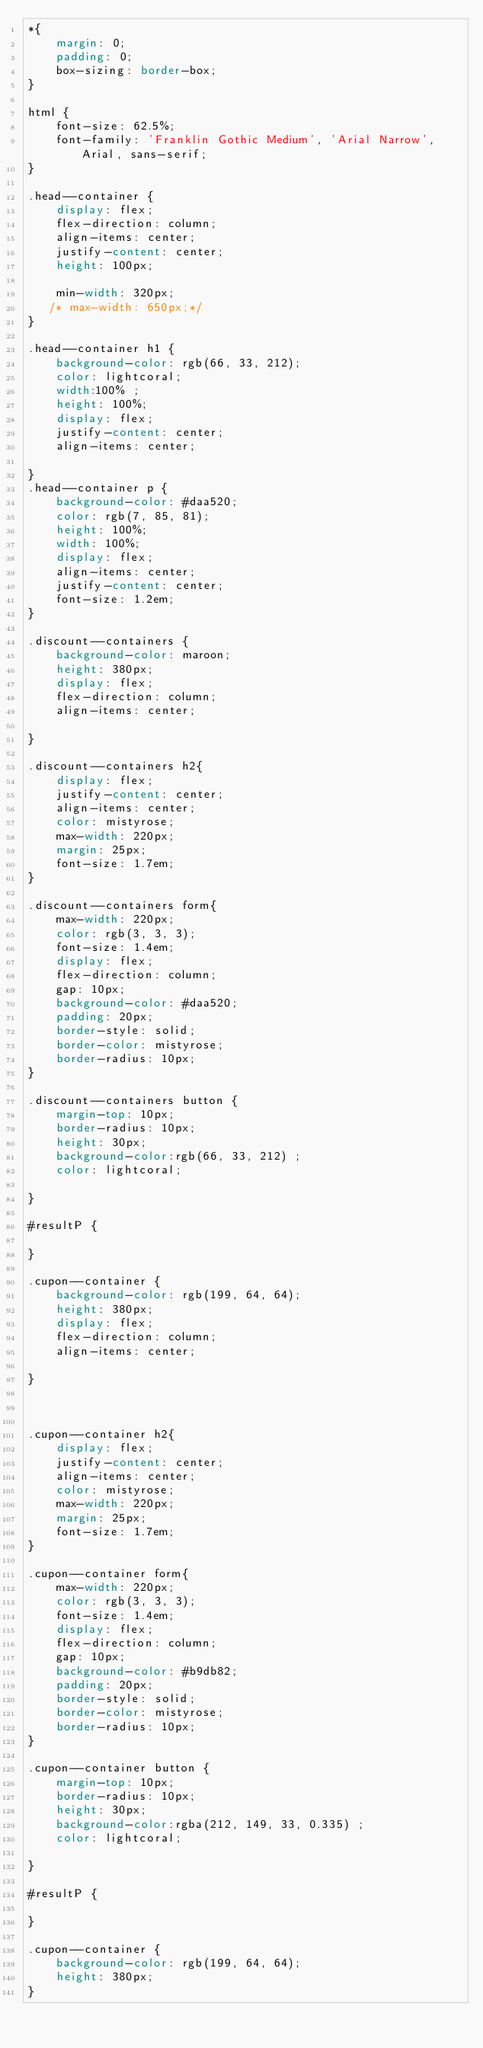<code> <loc_0><loc_0><loc_500><loc_500><_CSS_>*{
    margin: 0;
    padding: 0;
    box-sizing: border-box;
}

html {
    font-size: 62.5%;
    font-family: 'Franklin Gothic Medium', 'Arial Narrow', Arial, sans-serif;
}

.head--container {
    display: flex;
    flex-direction: column;
    align-items: center;
    justify-content: center;
    height: 100px;
   
    min-width: 320px;
   /* max-width: 650px;*/
}

.head--container h1 {
    background-color: rgb(66, 33, 212);
    color: lightcoral;
    width:100% ;
    height: 100%;
    display: flex;
    justify-content: center;
    align-items: center;

}
.head--container p {
    background-color: #daa520;
    color: rgb(7, 85, 81);
    height: 100%;
    width: 100%;
    display: flex;
    align-items: center;
    justify-content: center;
    font-size: 1.2em;
}

.discount--containers {
    background-color: maroon;
    height: 380px;
    display: flex;
    flex-direction: column;
    align-items: center;
    
}

.discount--containers h2{
    display: flex;
    justify-content: center;
    align-items: center;
    color: mistyrose;
    max-width: 220px;
    margin: 25px;
    font-size: 1.7em;
}

.discount--containers form{
    max-width: 220px;
    color: rgb(3, 3, 3);
    font-size: 1.4em;
    display: flex;
    flex-direction: column;
    gap: 10px;
    background-color: #daa520;
    padding: 20px;
    border-style: solid;
    border-color: mistyrose;
    border-radius: 10px;
}

.discount--containers button {
    margin-top: 10px;
    border-radius: 10px;
    height: 30px;
    background-color:rgb(66, 33, 212) ;
    color: lightcoral;

}

#resultP {
 
}

.cupon--container {
    background-color: rgb(199, 64, 64);
    height: 380px;
    display: flex;
    flex-direction: column;
    align-items: center;
    
}



.cupon--container h2{
    display: flex;
    justify-content: center;
    align-items: center;
    color: mistyrose;
    max-width: 220px;
    margin: 25px;
    font-size: 1.7em;
}

.cupon--container form{
    max-width: 220px;
    color: rgb(3, 3, 3);
    font-size: 1.4em;
    display: flex;
    flex-direction: column;
    gap: 10px;
    background-color: #b9db82;
    padding: 20px;
    border-style: solid;
    border-color: mistyrose;
    border-radius: 10px;
}

.cupon--container button {
    margin-top: 10px;
    border-radius: 10px;
    height: 30px;
    background-color:rgba(212, 149, 33, 0.335) ;
    color: lightcoral;

}

#resultP {
 
}

.cupon--container {
    background-color: rgb(199, 64, 64);
    height: 380px;
}
 

</code> 